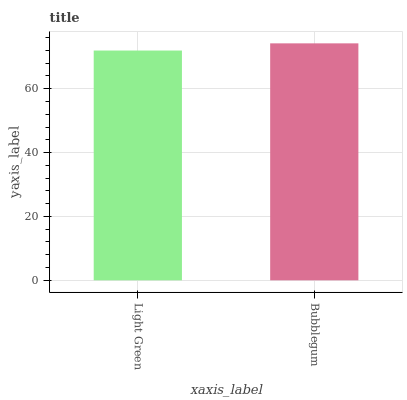Is Light Green the minimum?
Answer yes or no. Yes. Is Bubblegum the maximum?
Answer yes or no. Yes. Is Bubblegum the minimum?
Answer yes or no. No. Is Bubblegum greater than Light Green?
Answer yes or no. Yes. Is Light Green less than Bubblegum?
Answer yes or no. Yes. Is Light Green greater than Bubblegum?
Answer yes or no. No. Is Bubblegum less than Light Green?
Answer yes or no. No. Is Bubblegum the high median?
Answer yes or no. Yes. Is Light Green the low median?
Answer yes or no. Yes. Is Light Green the high median?
Answer yes or no. No. Is Bubblegum the low median?
Answer yes or no. No. 